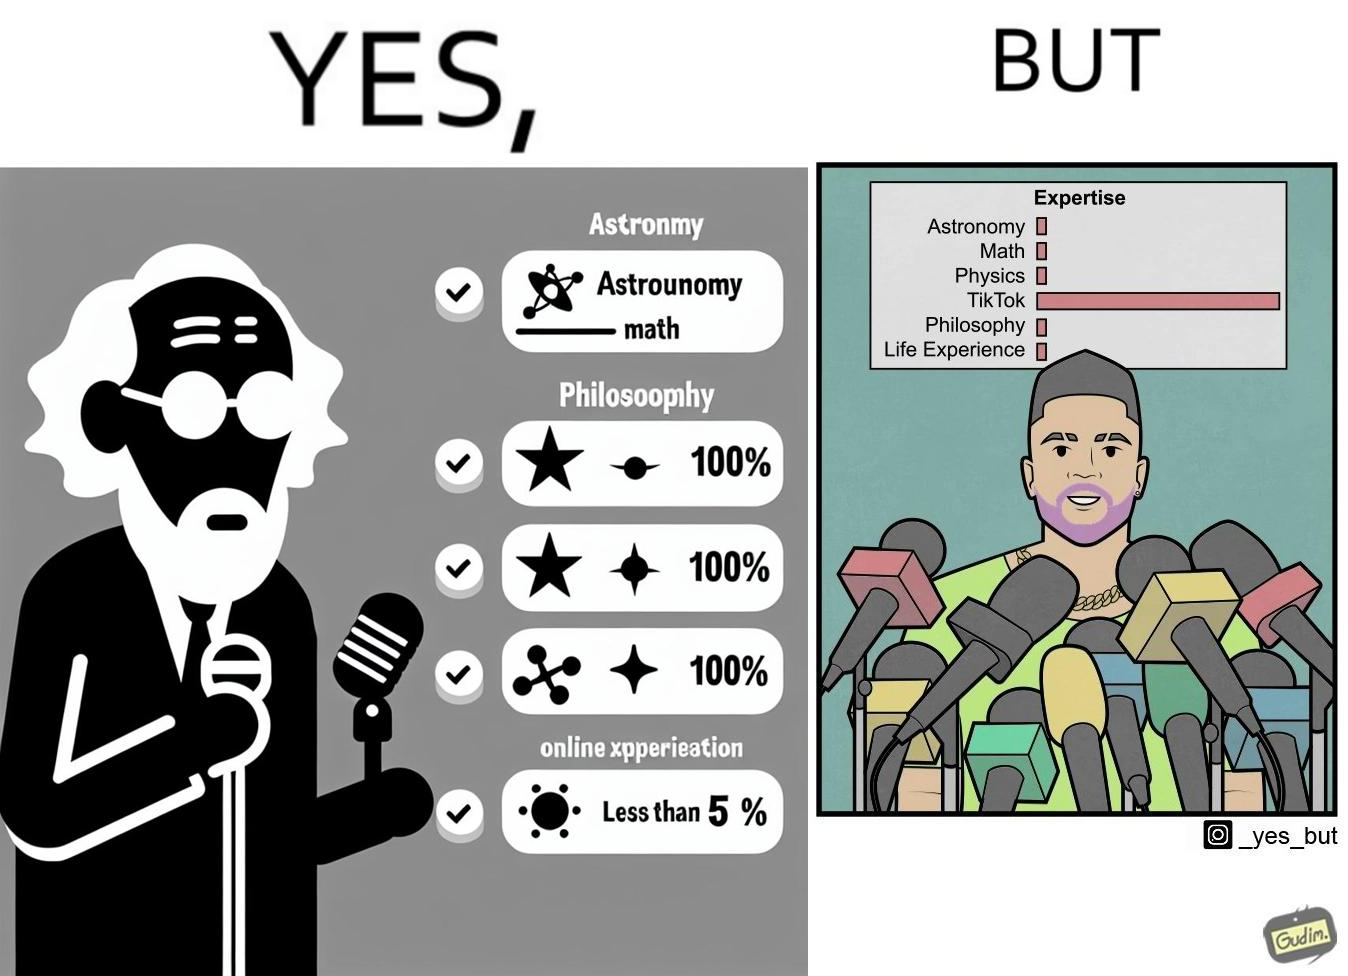What does this image depict? The image is satirical beacause it shows that people with more tiktok expertise are treated more importantly than the ones who are expert in all the other areas but tiktok. Here, the number of microphones a man speaks into is indicative of his importance. 